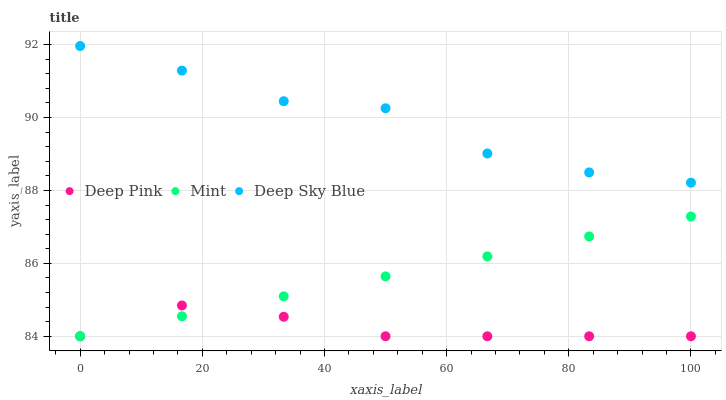Does Deep Pink have the minimum area under the curve?
Answer yes or no. Yes. Does Deep Sky Blue have the maximum area under the curve?
Answer yes or no. Yes. Does Mint have the minimum area under the curve?
Answer yes or no. No. Does Mint have the maximum area under the curve?
Answer yes or no. No. Is Mint the smoothest?
Answer yes or no. Yes. Is Deep Sky Blue the roughest?
Answer yes or no. Yes. Is Deep Sky Blue the smoothest?
Answer yes or no. No. Is Mint the roughest?
Answer yes or no. No. Does Deep Pink have the lowest value?
Answer yes or no. Yes. Does Deep Sky Blue have the lowest value?
Answer yes or no. No. Does Deep Sky Blue have the highest value?
Answer yes or no. Yes. Does Mint have the highest value?
Answer yes or no. No. Is Deep Pink less than Deep Sky Blue?
Answer yes or no. Yes. Is Deep Sky Blue greater than Mint?
Answer yes or no. Yes. Does Mint intersect Deep Pink?
Answer yes or no. Yes. Is Mint less than Deep Pink?
Answer yes or no. No. Is Mint greater than Deep Pink?
Answer yes or no. No. Does Deep Pink intersect Deep Sky Blue?
Answer yes or no. No. 